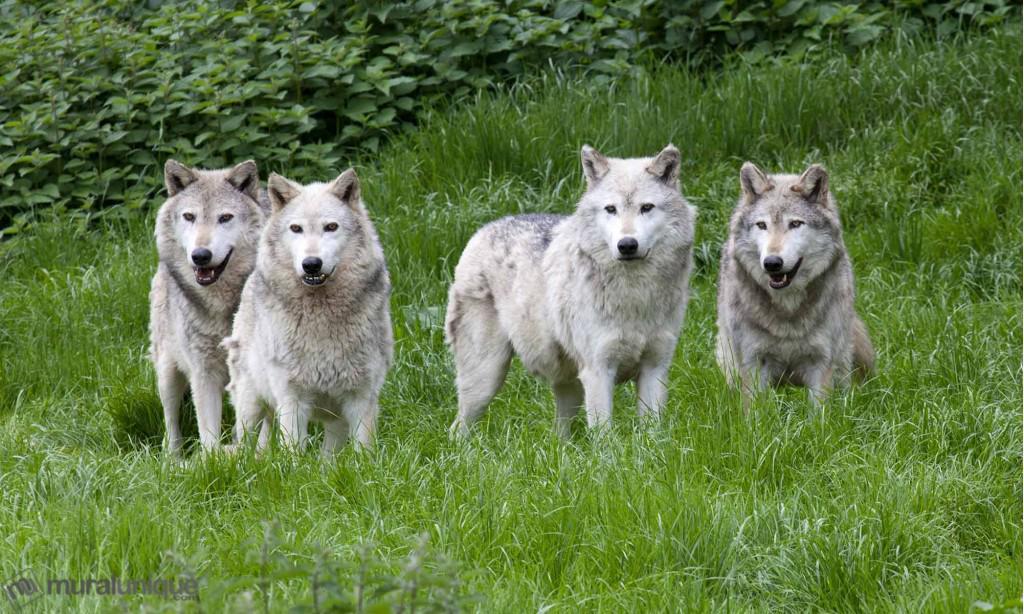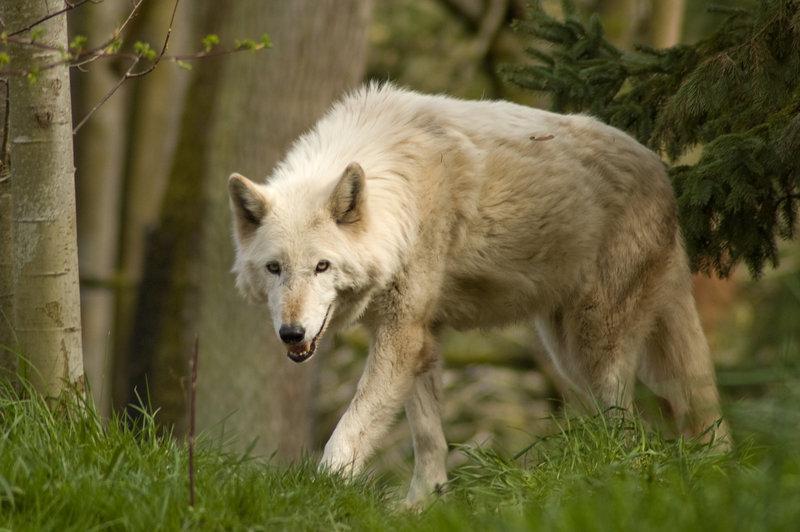The first image is the image on the left, the second image is the image on the right. Assess this claim about the two images: "There are five wolves in total.". Correct or not? Answer yes or no. Yes. The first image is the image on the left, the second image is the image on the right. Given the left and right images, does the statement "The right image contains no more than one wolf." hold true? Answer yes or no. Yes. 